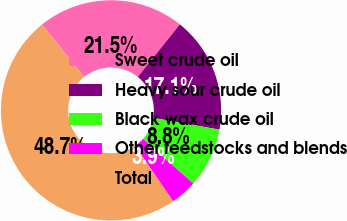Convert chart to OTSL. <chart><loc_0><loc_0><loc_500><loc_500><pie_chart><fcel>Sweet crude oil<fcel>Heavy sour crude oil<fcel>Black wax crude oil<fcel>Other feedstocks and blends<fcel>Total<nl><fcel>21.54%<fcel>17.06%<fcel>8.77%<fcel>3.9%<fcel>48.73%<nl></chart> 